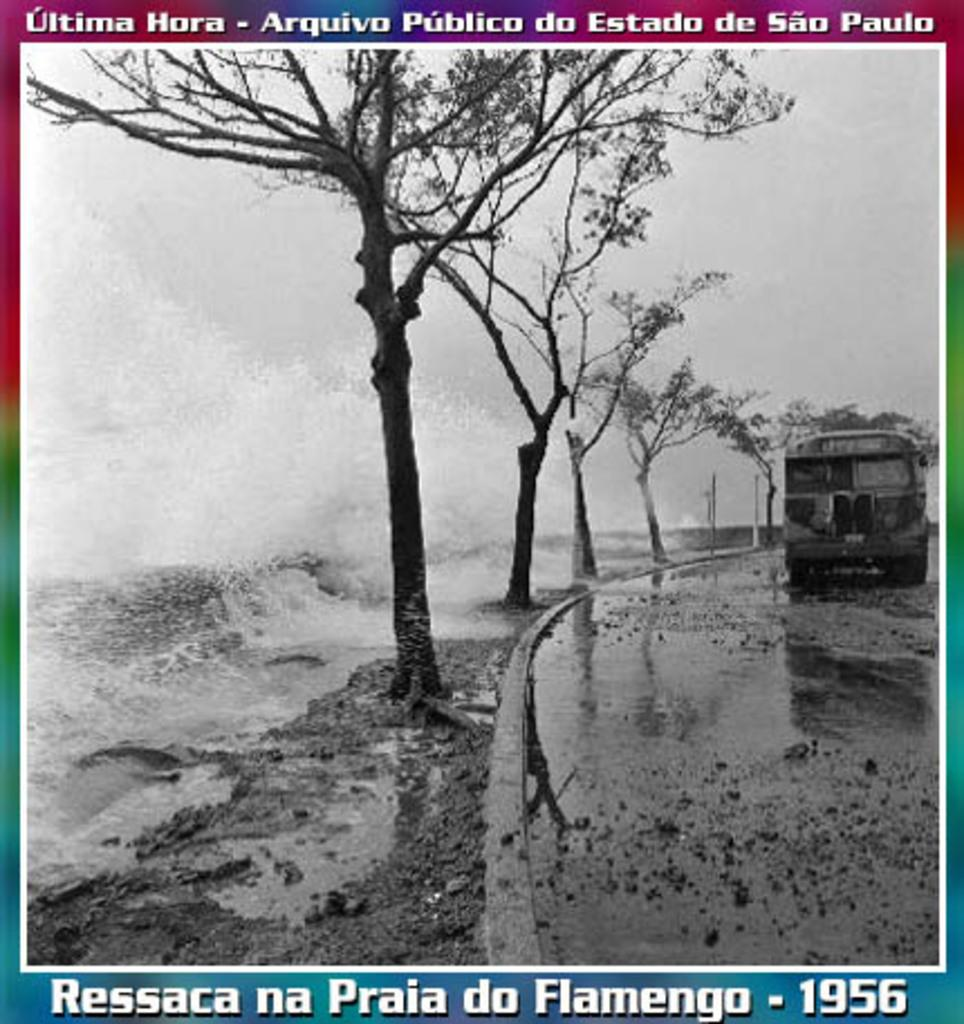<image>
Render a clear and concise summary of the photo. An original historical image from 1956 ofSao Paulo by Ressaca na Praia do Flamengo 